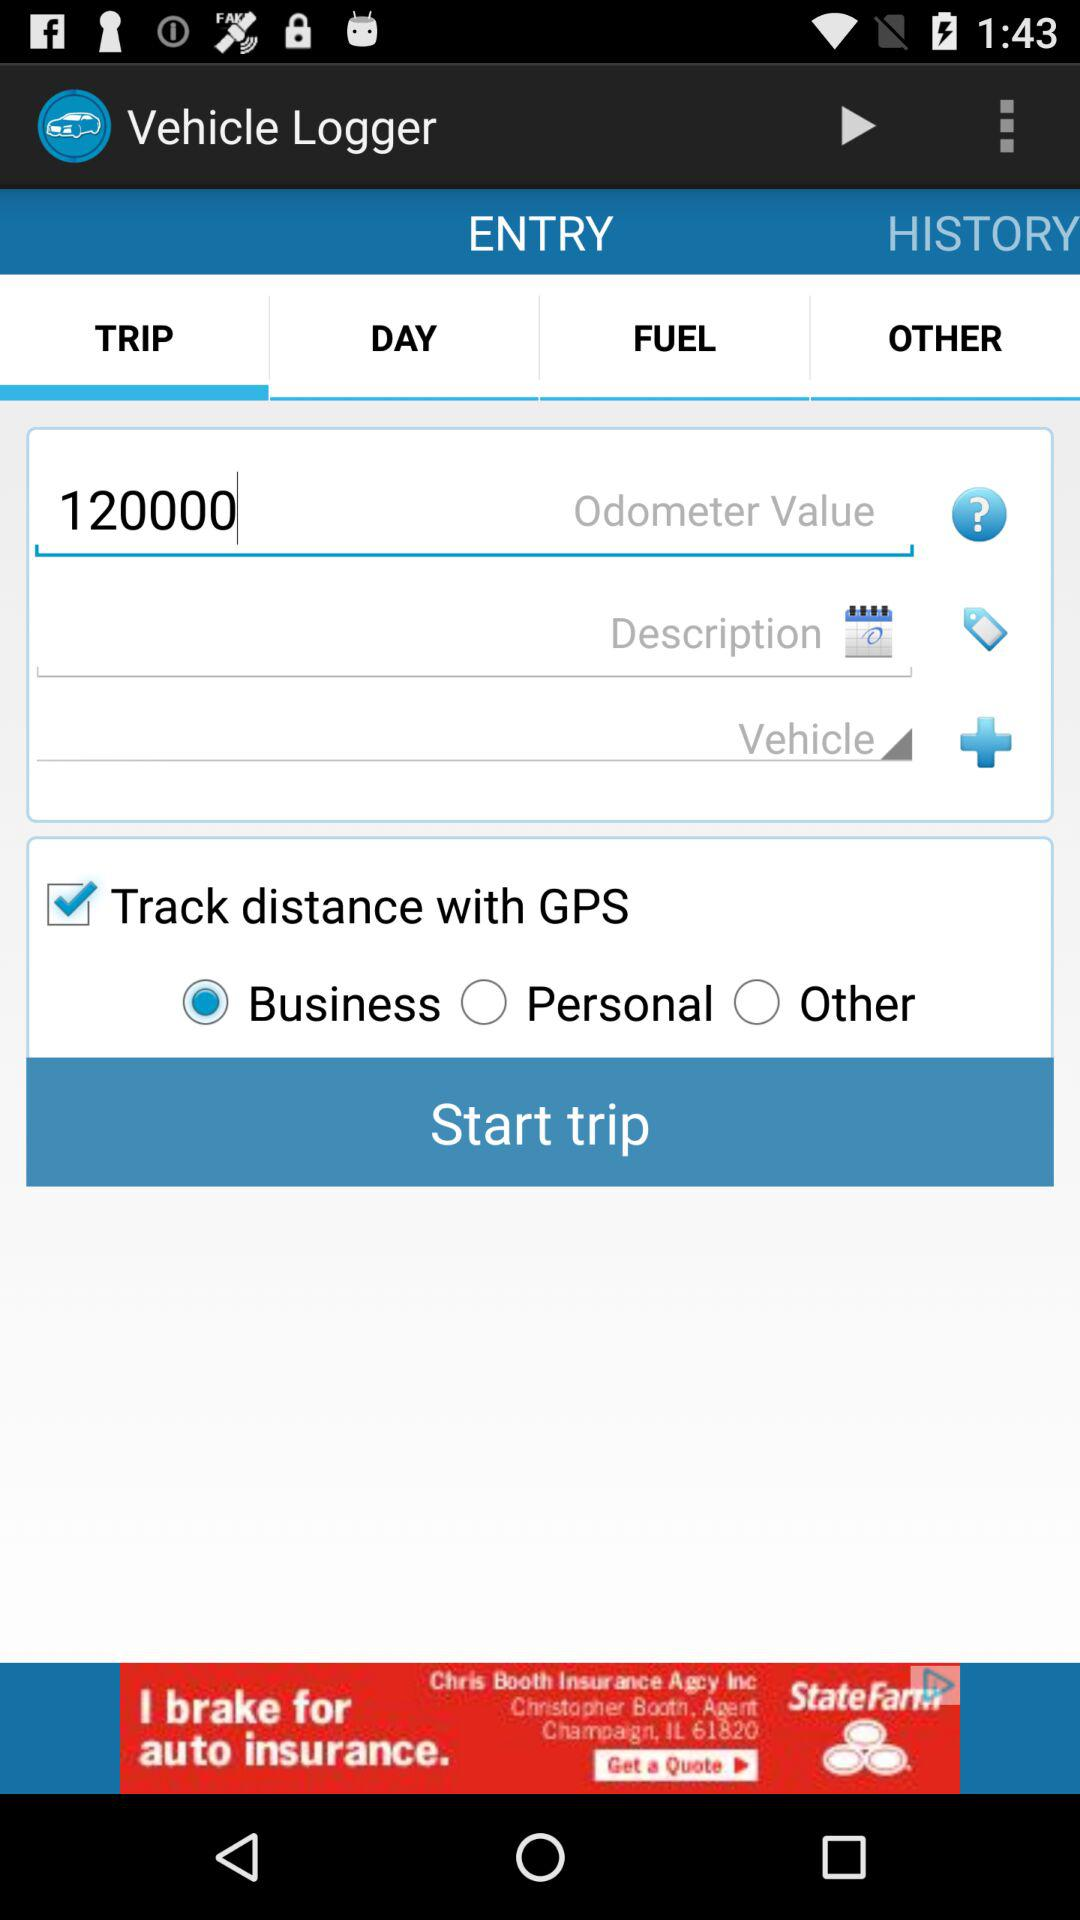What tab is selected? The selected tab is "TRIP". 